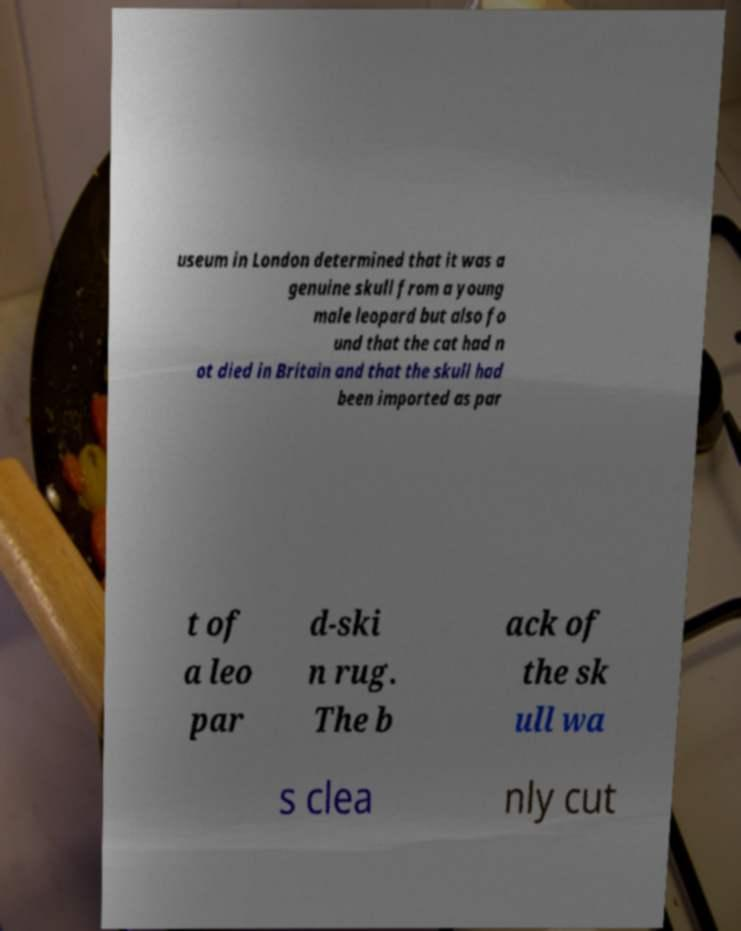For documentation purposes, I need the text within this image transcribed. Could you provide that? useum in London determined that it was a genuine skull from a young male leopard but also fo und that the cat had n ot died in Britain and that the skull had been imported as par t of a leo par d-ski n rug. The b ack of the sk ull wa s clea nly cut 